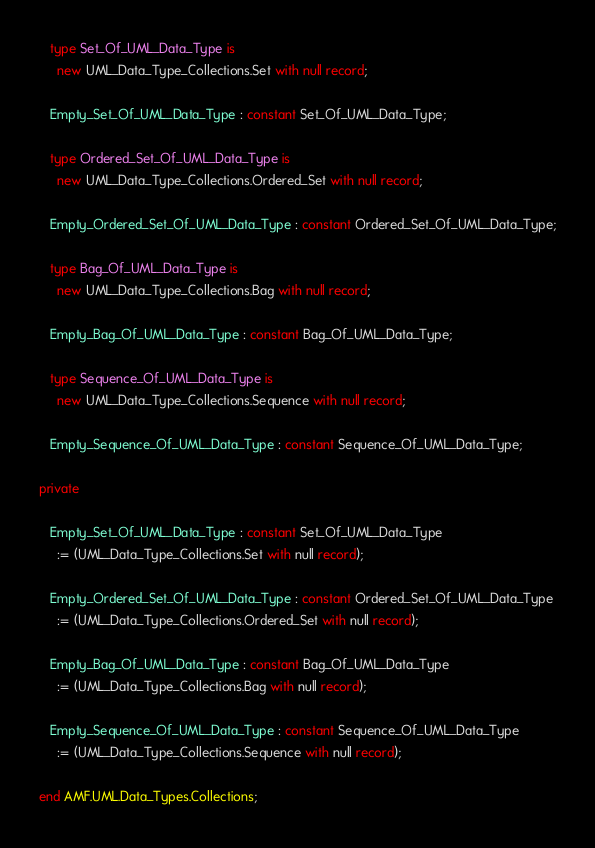Convert code to text. <code><loc_0><loc_0><loc_500><loc_500><_Ada_>
   type Set_Of_UML_Data_Type is
     new UML_Data_Type_Collections.Set with null record;

   Empty_Set_Of_UML_Data_Type : constant Set_Of_UML_Data_Type;

   type Ordered_Set_Of_UML_Data_Type is
     new UML_Data_Type_Collections.Ordered_Set with null record;

   Empty_Ordered_Set_Of_UML_Data_Type : constant Ordered_Set_Of_UML_Data_Type;

   type Bag_Of_UML_Data_Type is
     new UML_Data_Type_Collections.Bag with null record;

   Empty_Bag_Of_UML_Data_Type : constant Bag_Of_UML_Data_Type;

   type Sequence_Of_UML_Data_Type is
     new UML_Data_Type_Collections.Sequence with null record;

   Empty_Sequence_Of_UML_Data_Type : constant Sequence_Of_UML_Data_Type;

private

   Empty_Set_Of_UML_Data_Type : constant Set_Of_UML_Data_Type
     := (UML_Data_Type_Collections.Set with null record);

   Empty_Ordered_Set_Of_UML_Data_Type : constant Ordered_Set_Of_UML_Data_Type
     := (UML_Data_Type_Collections.Ordered_Set with null record);

   Empty_Bag_Of_UML_Data_Type : constant Bag_Of_UML_Data_Type
     := (UML_Data_Type_Collections.Bag with null record);

   Empty_Sequence_Of_UML_Data_Type : constant Sequence_Of_UML_Data_Type
     := (UML_Data_Type_Collections.Sequence with null record);

end AMF.UML.Data_Types.Collections;
</code> 